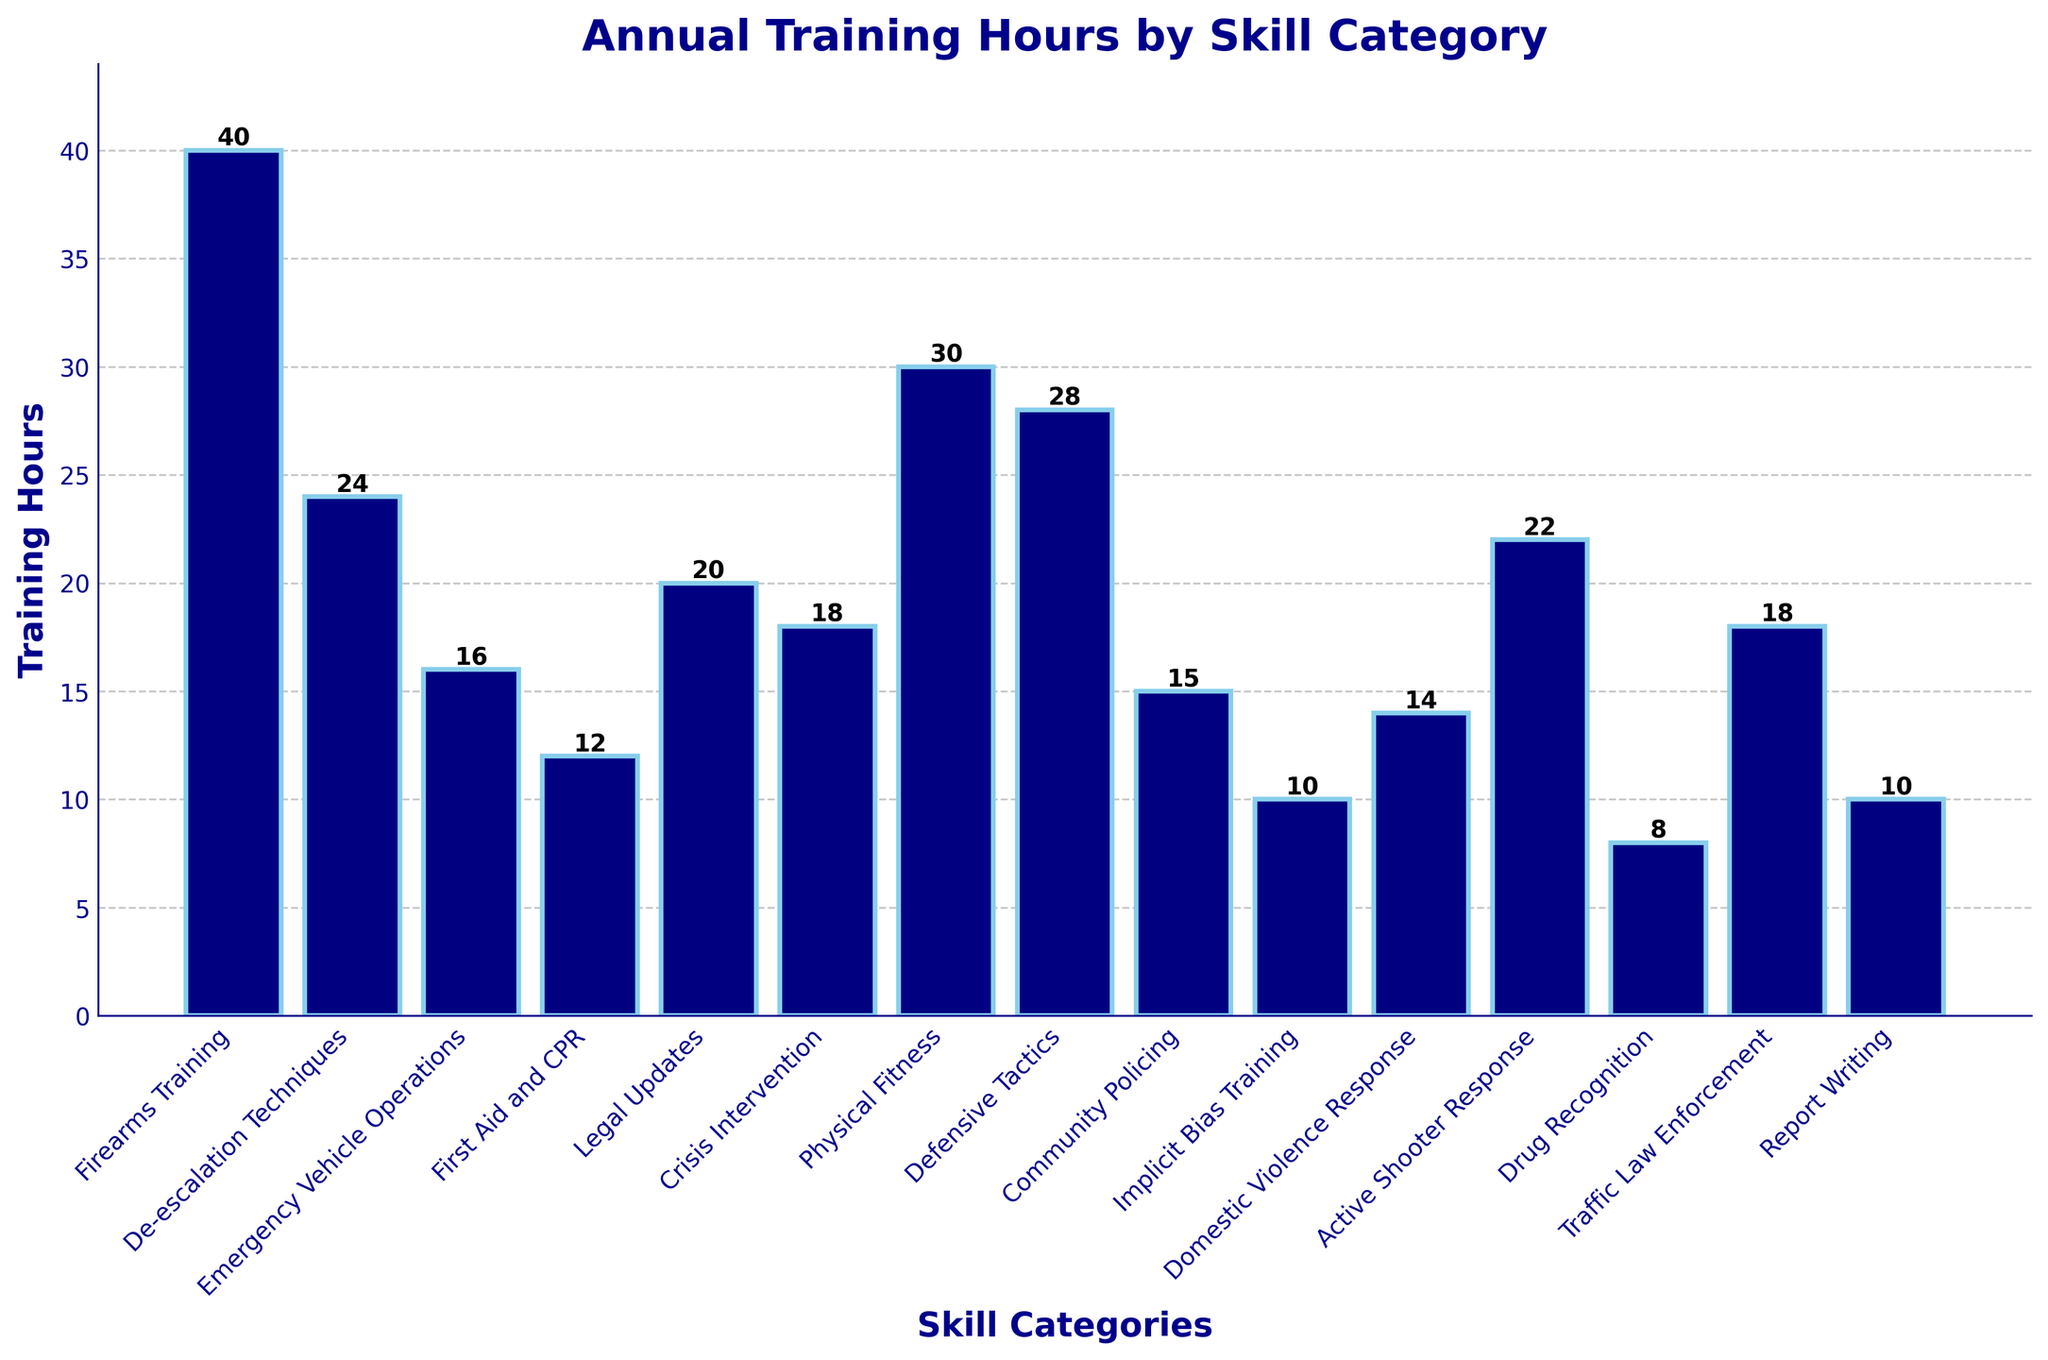Which skill category has the highest training hours? Look at the height of the bars. The tallest bar represents the skill category with the highest training hours. According to the chart, "Firearms Training" has the tallest bar.
Answer: Firearms Training What is the total training hours for "First Aid and CPR" and "Defensive Tactics"? Refer to the bars representing "First Aid and CPR" and "Defensive Tactics". The heights of these bars are 12 hours and 28 hours, respectively. Add these values together: 12 + 28 = 40.
Answer: 40 Which skill category has fewer training hours: "Implicit Bias Training" or "Drug Recognition"? Check the bars for "Implicit Bias Training" and "Drug Recognition". The height for "Implicit Bias Training" is 10 hours, and for "Drug Recognition" it is 8 hours. 8 is less than 10, so "Drug Recognition" has fewer training hours.
Answer: Drug Recognition How many skill categories have training hours between 15 and 25? Identify the bars with heights between 15 and 25 hours. These bars represent the categories: "De-escalation Techniques", "Legal Updates", "Crisis Intervention", "Community Policing", "Active Shooter Response", and "Traffic Law Enforcement". Count these categories: 6.
Answer: 6 What is the difference in training hours between "Physical Fitness" and "Emergency Vehicle Operations"? Find the heights of the bars for "Physical Fitness" and "Emergency Vehicle Operations". They are 30 hours and 16 hours, respectively. Subtract the smaller value from the larger: 30 - 16 = 14.
Answer: 14 Which skill categories have training hours equal to 10? Look at the bars with a height of 10 hours. Those bars represent "Implicit Bias Training" and "Report Writing".
Answer: Implicit Bias Training, Report Writing What is the combined training hours for categories starting with the letter "D"? Identify the bars for categories starting with "D": "De-escalation Techniques" (24 hours), "Defensive Tactics" (28 hours), "Drug Recognition" (8 hours), "Domestic Violence Response" (14 hours). Add these values: 24 + 28 + 8 + 14 = 74.
Answer: 74 